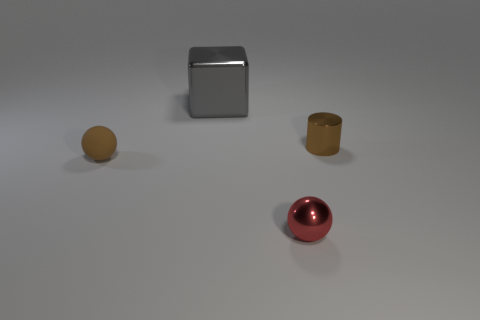There is a red thing that is the same material as the cube; what is its shape?
Offer a very short reply. Sphere. How many shiny objects are either small things or big gray blocks?
Make the answer very short. 3. What number of red shiny spheres are on the left side of the small brown thing right of the small brown thing to the left of the gray object?
Offer a very short reply. 1. There is a ball that is on the right side of the gray block; is it the same size as the brown object that is on the right side of the gray object?
Offer a terse response. Yes. What is the material of the other object that is the same shape as the red thing?
Offer a very short reply. Rubber. What number of big things are either gray metal blocks or brown objects?
Give a very brief answer. 1. What is the cube made of?
Offer a very short reply. Metal. What material is the small thing that is in front of the small cylinder and behind the red metal object?
Provide a short and direct response. Rubber. Is the color of the cylinder the same as the object to the left of the gray metallic cube?
Your answer should be compact. Yes. What material is the brown ball that is the same size as the brown cylinder?
Offer a very short reply. Rubber. 